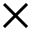<formula> <loc_0><loc_0><loc_500><loc_500>\times</formula> 